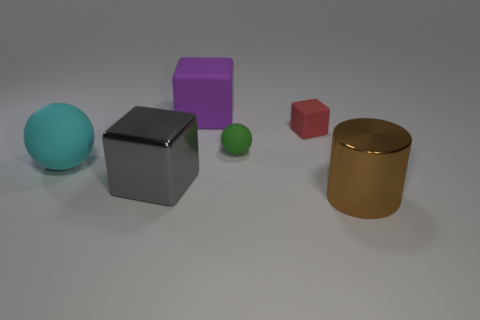Is there any significance to the arrangement of the objects? The arrangement of these objects seems rather arbitrary and does not immediately suggest a specific intentional pattern or significance. They are spread out across a flat surface with some objects closer to the foreground and others towards the background, which might indicate a casual placement rather than a structured setup. Could this arrangement be used as an educational tool? Yes, this image could serve educational purposes, such as teaching concepts of color, geometry, size comparison, perspectives in photography, or even materials and their properties. For younger learners, it might also be used to introduce basic shapes and colors. 